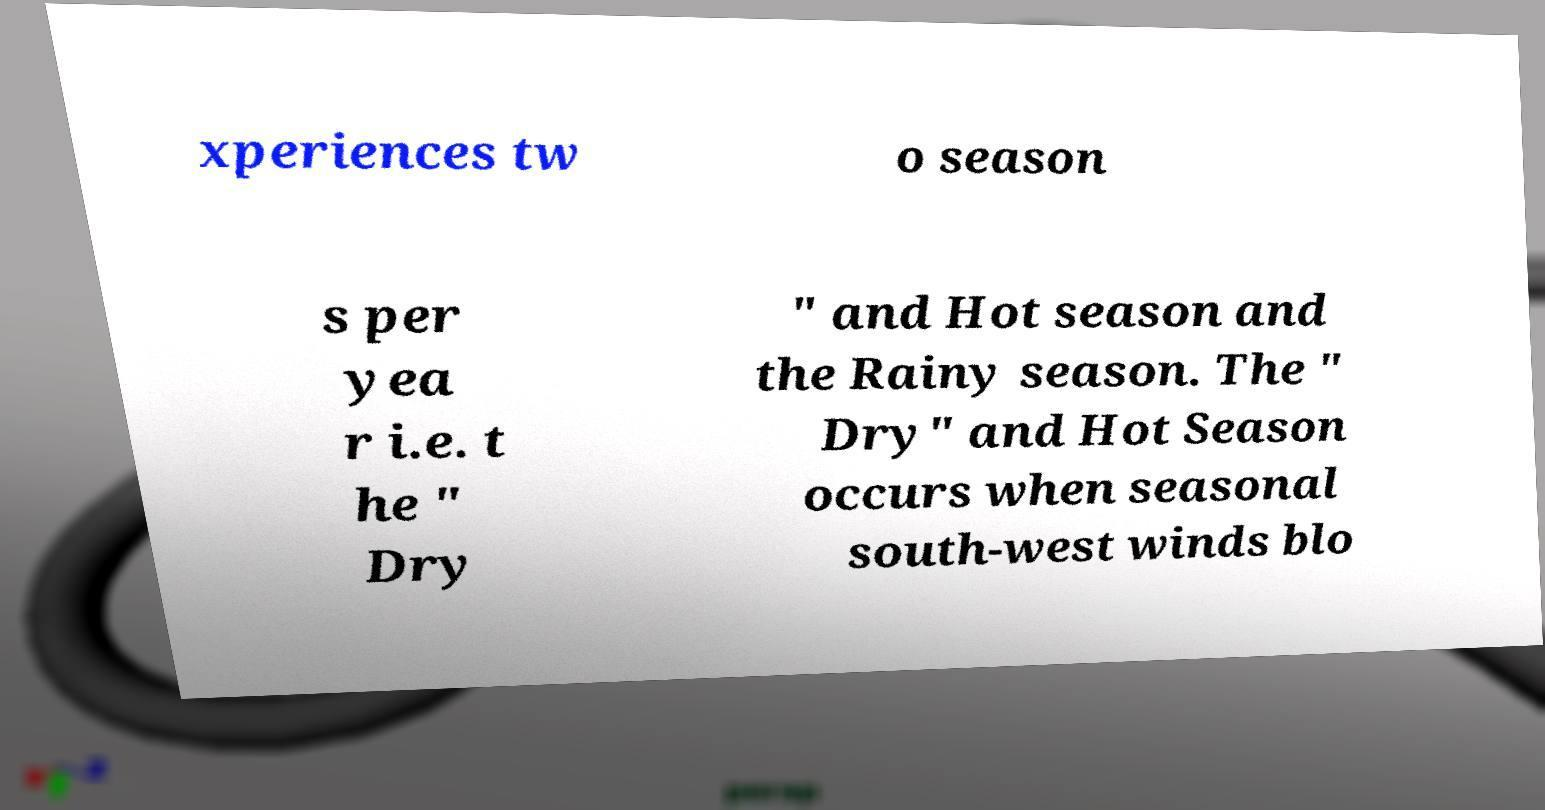Can you read and provide the text displayed in the image?This photo seems to have some interesting text. Can you extract and type it out for me? xperiences tw o season s per yea r i.e. t he " Dry " and Hot season and the Rainy season. The " Dry" and Hot Season occurs when seasonal south-west winds blo 